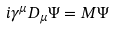Convert formula to latex. <formula><loc_0><loc_0><loc_500><loc_500>i \gamma ^ { \mu } { D } _ { \mu } \Psi = { M } \Psi</formula> 